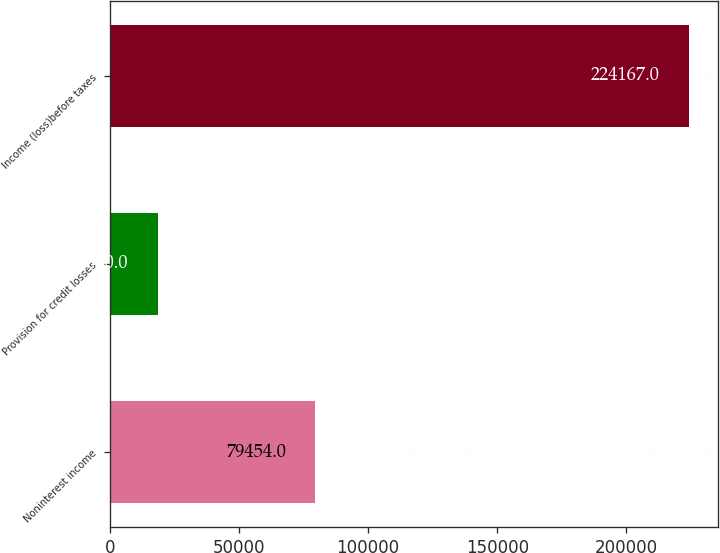Convert chart to OTSL. <chart><loc_0><loc_0><loc_500><loc_500><bar_chart><fcel>Noninterest income<fcel>Provision for credit losses<fcel>Income (loss)before taxes<nl><fcel>79454<fcel>18580<fcel>224167<nl></chart> 